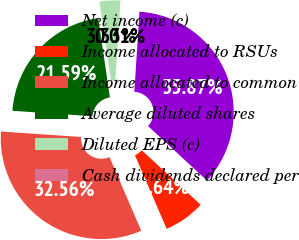Convert chart. <chart><loc_0><loc_0><loc_500><loc_500><pie_chart><fcel>Net income (c)<fcel>Income allocated to RSUs<fcel>Income allocated to common<fcel>Average diluted shares<fcel>Diluted EPS (c)<fcel>Cash dividends declared per<nl><fcel>35.87%<fcel>6.64%<fcel>32.56%<fcel>21.59%<fcel>3.33%<fcel>0.01%<nl></chart> 